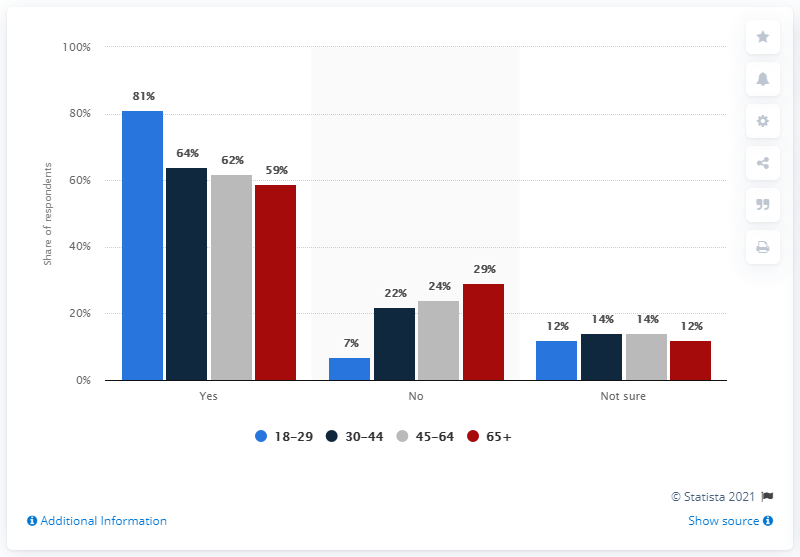List a handful of essential elements in this visual. The value of the highest bar in the chart is 81. There are 8 bars in the chart below 40%. 